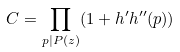Convert formula to latex. <formula><loc_0><loc_0><loc_500><loc_500>C = \prod _ { p | P ( z ) } ( 1 + h ^ { \prime } h ^ { \prime \prime } ( p ) )</formula> 